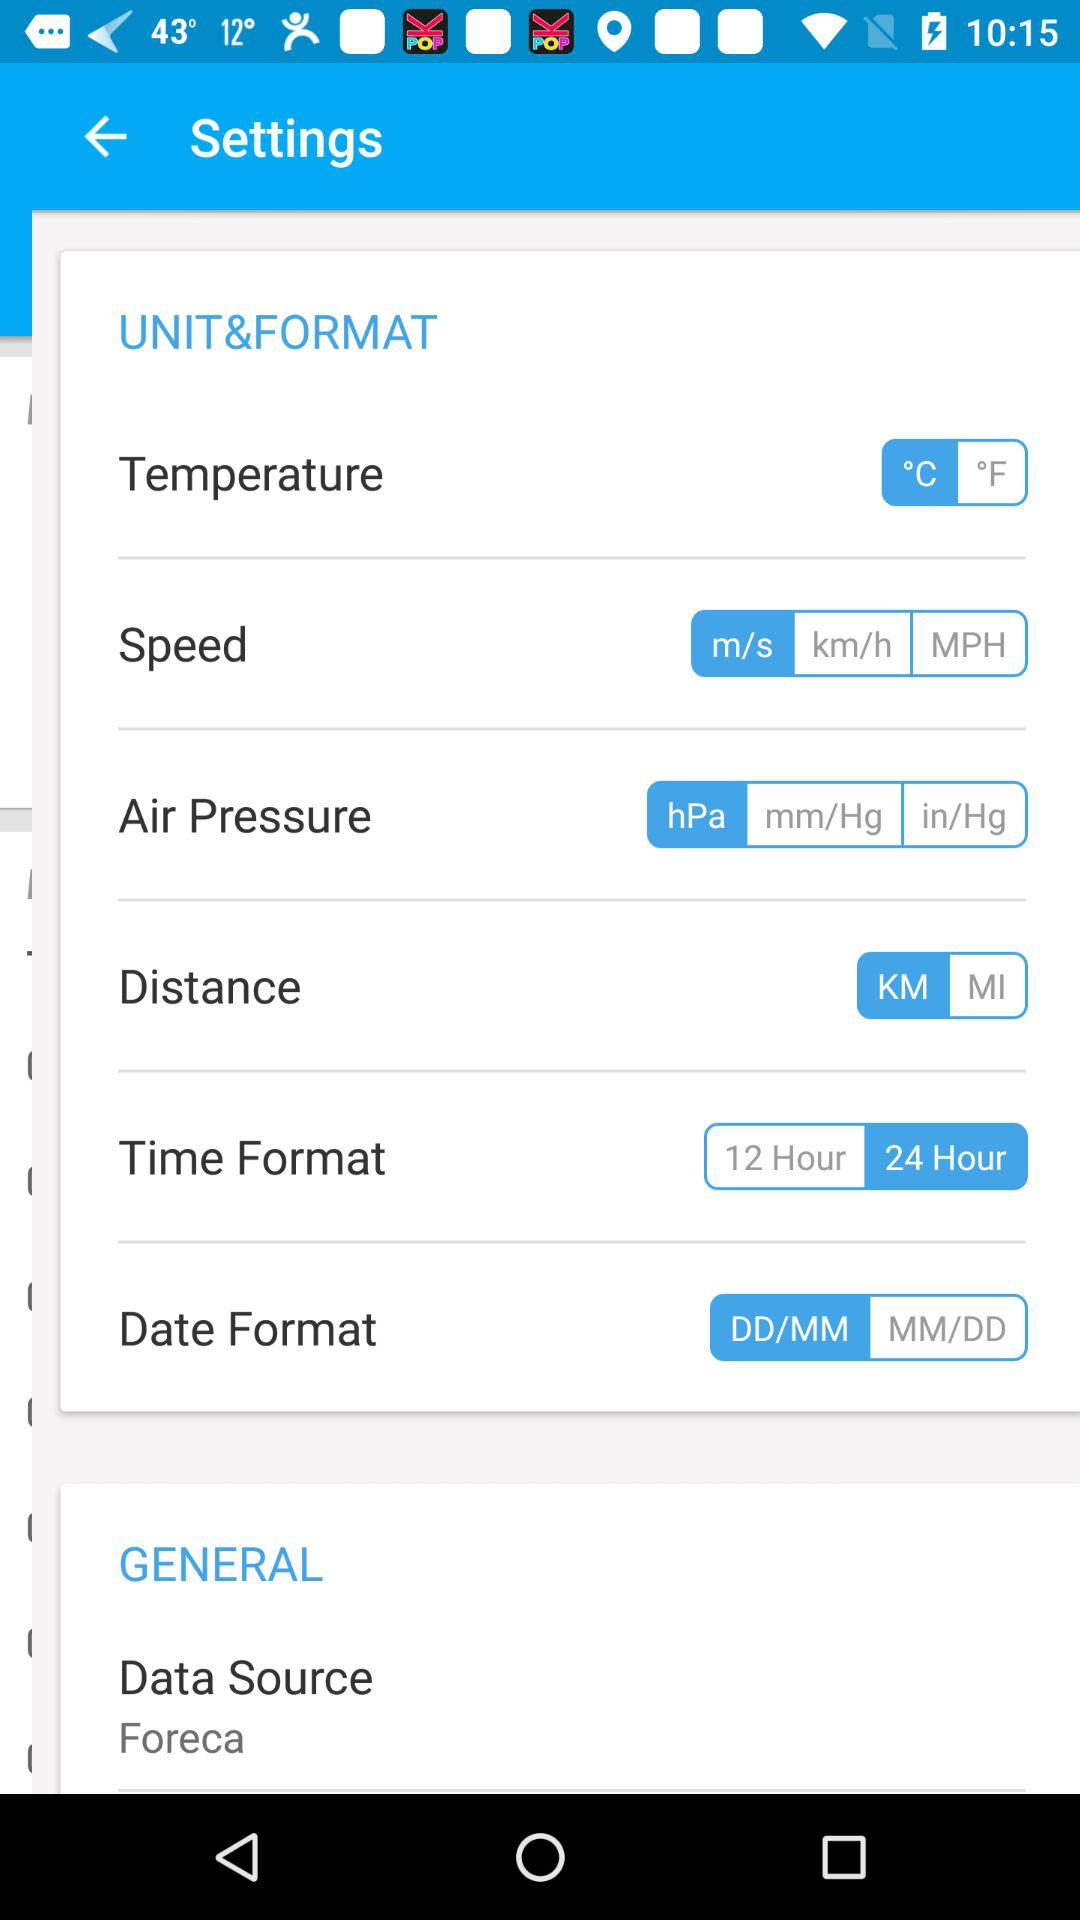Which temperature unit is selected? The selected temperature unit is degree Celsius. 